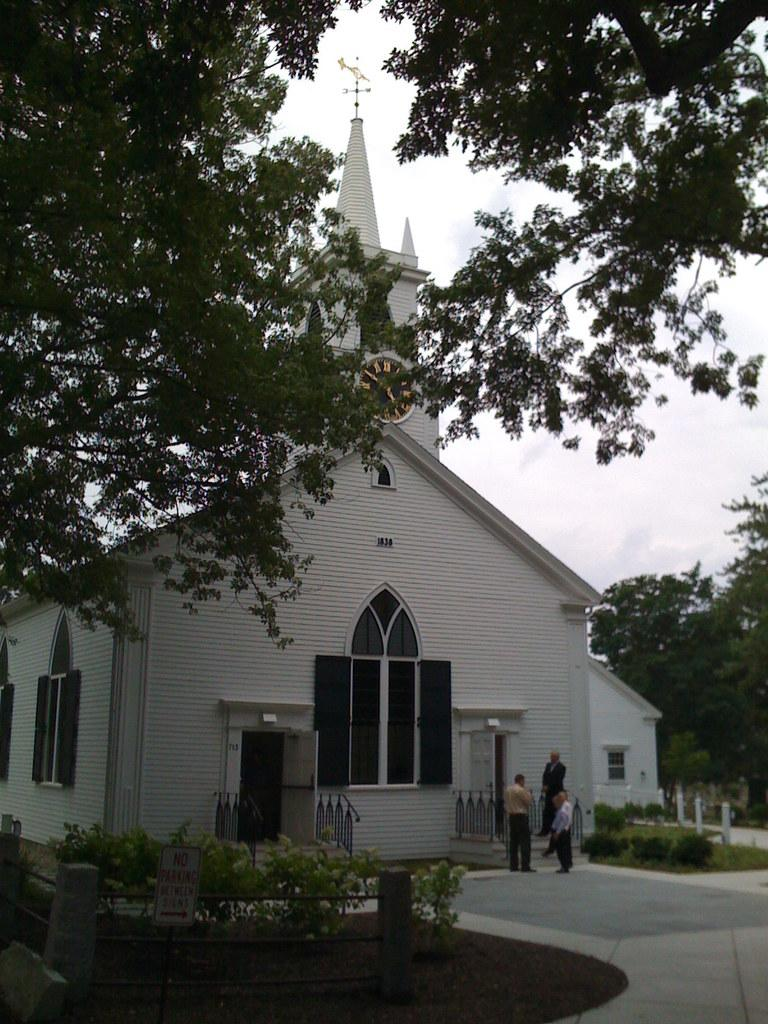What type of structure is present in the image? There is a building in the image. What time-telling device can be seen in the image? There is a clock in the image. What type of vegetation is present in the image? There are trees and plants in the image. Where are the people located in the image? The people are in front of the building. What can be seen in the background of the image? There are clouds visible in the background. What type of locket is hanging from the tree in the image? There is no locket present in the image; it features a building, a clock, trees, plants, people, and clouds. What type of teeth can be seen in the image? There are no teeth visible in the image. 